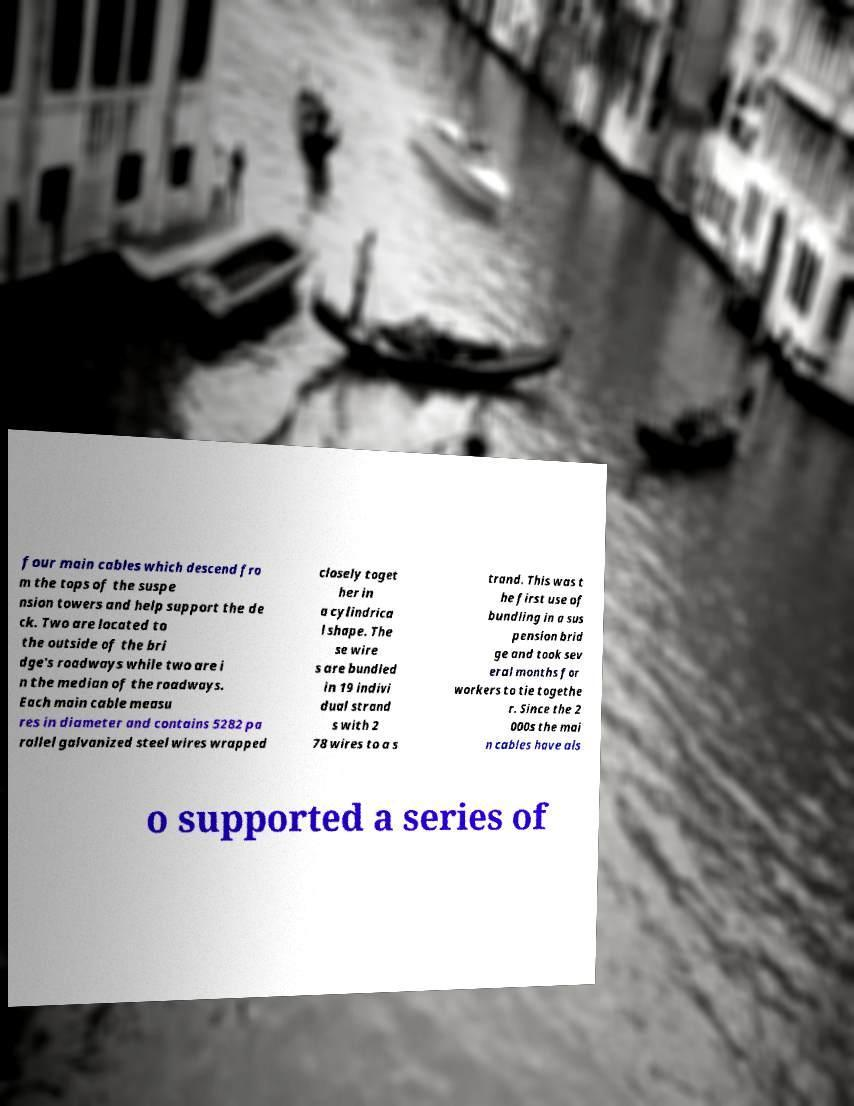Please read and relay the text visible in this image. What does it say? four main cables which descend fro m the tops of the suspe nsion towers and help support the de ck. Two are located to the outside of the bri dge's roadways while two are i n the median of the roadways. Each main cable measu res in diameter and contains 5282 pa rallel galvanized steel wires wrapped closely toget her in a cylindrica l shape. The se wire s are bundled in 19 indivi dual strand s with 2 78 wires to a s trand. This was t he first use of bundling in a sus pension brid ge and took sev eral months for workers to tie togethe r. Since the 2 000s the mai n cables have als o supported a series of 